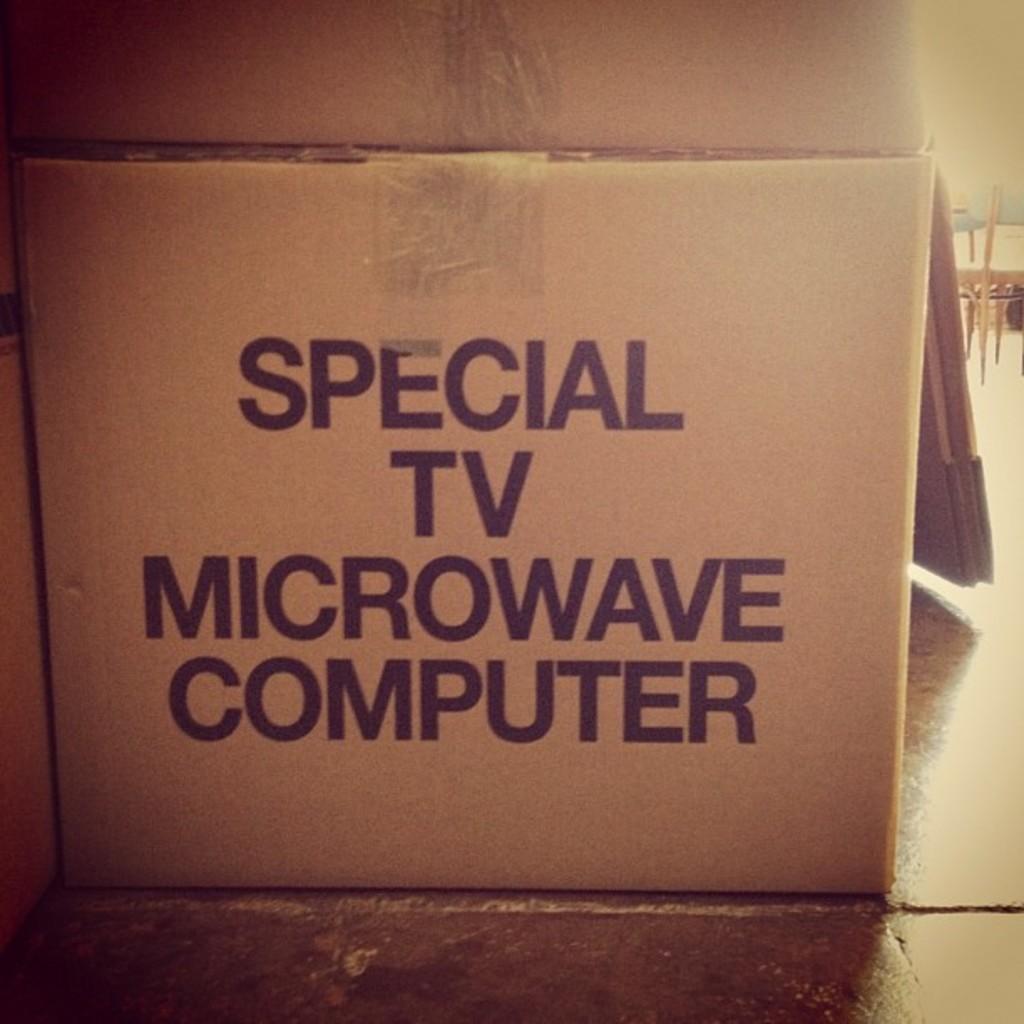How many electronics are listed on the box?
Your response must be concise. 3. What is the last word in the picture?
Your response must be concise. Computer. 